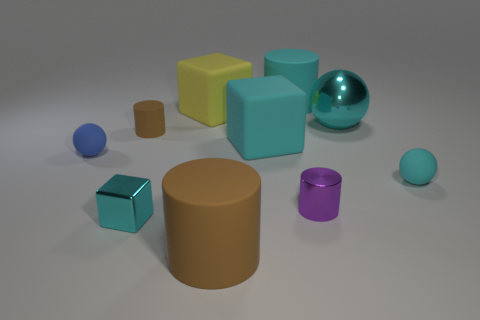Subtract 1 cylinders. How many cylinders are left? 3 Subtract 1 purple cylinders. How many objects are left? 9 Subtract all spheres. How many objects are left? 7 Subtract all large brown cylinders. Subtract all small shiny blocks. How many objects are left? 8 Add 4 cyan objects. How many cyan objects are left? 9 Add 6 purple metal things. How many purple metal things exist? 7 